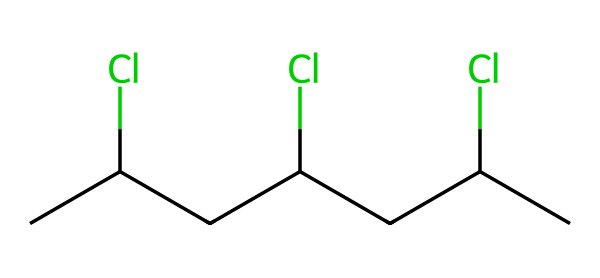What is the molecular formula of this chemical? The SMILES representation of the chemical indicates the number of carbon (C) and chlorine (Cl) atoms in the structure. Counting the number of carbon atoms gives 4 and there are 4 chlorine atoms attached to them. Therefore, the molecular formula is C4H4Cl4.
Answer: C4H4Cl4 How many carbon atoms are present in the structure? The chemical structure, as represented in the SMILES notation, contains 4 carbon atoms. They are denoted as the 'C' characters in the SMILES.
Answer: 4 What type of polymer does this chemical represent? Polyvinyl chloride (PVC) is a common polymer represented by this specific SMILES structure due to its repeating units of vinyl and chlorine substitutes.
Answer: PVC What is the effect of chlorine substituents on the polymer's properties? The presence of chlorine atoms in polyvinyl chloride increases the polymer's density, stability, and fire resistance while also affecting its flexibility compared to other polymers without chlorine substituents.
Answer: Increases stability How many chlorine atoms are in this molecule? The SMILES representation indicates that there are 4 chlorine atoms present in the chemical structure, as seen with the 'Cl' symbols.
Answer: 4 What type of bonding is present between carbon and chlorine in this structure? The bonding between carbon and chlorine in this polymer is covalent, where electrons are shared between these atoms, which is typical in organic compounds and polymers.
Answer: Covalent How does the polymer chain length affect the physical properties of PVC? Longer polymer chains generally enhance the mechanical strength and rigidity of PVC, leading to improved durability and stress resistance, while shorter chains may lead to a more flexible material.
Answer: Increases strength and rigidity 